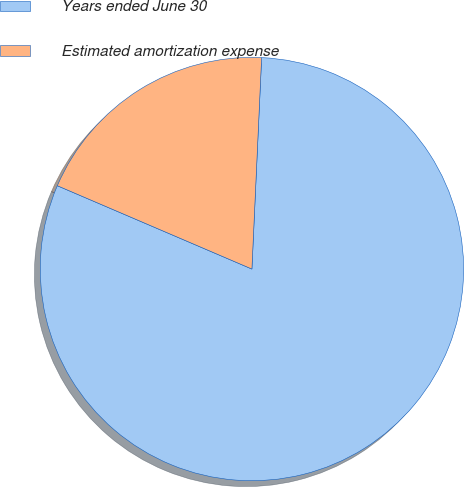<chart> <loc_0><loc_0><loc_500><loc_500><pie_chart><fcel>Years ended June 30<fcel>Estimated amortization expense<nl><fcel>80.71%<fcel>19.29%<nl></chart> 